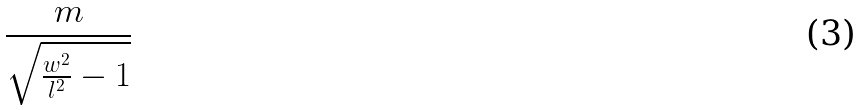Convert formula to latex. <formula><loc_0><loc_0><loc_500><loc_500>\frac { m } { \sqrt { \frac { w ^ { 2 } } { l ^ { 2 } } - 1 } }</formula> 